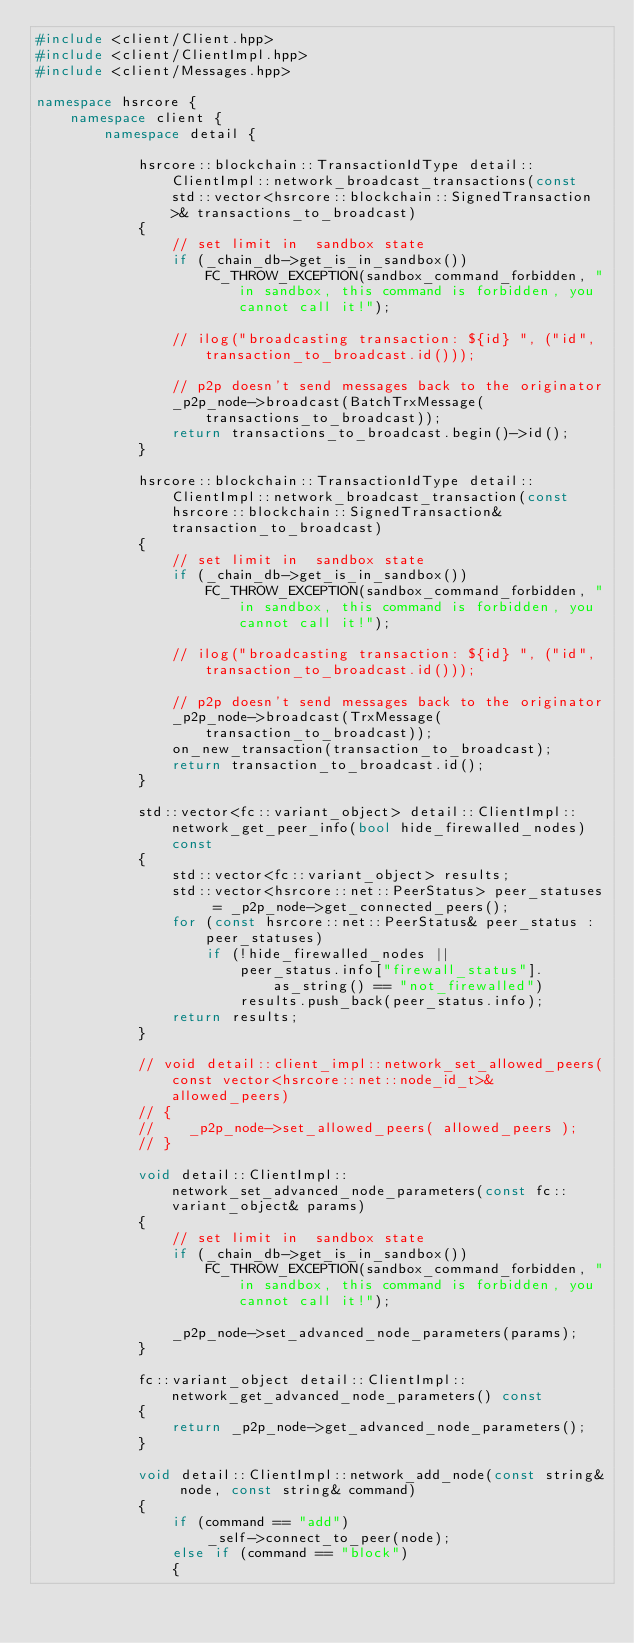<code> <loc_0><loc_0><loc_500><loc_500><_C++_>#include <client/Client.hpp>
#include <client/ClientImpl.hpp>
#include <client/Messages.hpp>

namespace hsrcore {
    namespace client {
        namespace detail {

            hsrcore::blockchain::TransactionIdType detail::ClientImpl::network_broadcast_transactions(const std::vector<hsrcore::blockchain::SignedTransaction>& transactions_to_broadcast)
            {
                // set limit in  sandbox state
                if (_chain_db->get_is_in_sandbox())
                    FC_THROW_EXCEPTION(sandbox_command_forbidden, "in sandbox, this command is forbidden, you cannot call it!");

                // ilog("broadcasting transaction: ${id} ", ("id", transaction_to_broadcast.id()));

                // p2p doesn't send messages back to the originator
                _p2p_node->broadcast(BatchTrxMessage(transactions_to_broadcast));
                return transactions_to_broadcast.begin()->id();
            }

            hsrcore::blockchain::TransactionIdType detail::ClientImpl::network_broadcast_transaction(const hsrcore::blockchain::SignedTransaction& transaction_to_broadcast)
            {
                // set limit in  sandbox state
                if (_chain_db->get_is_in_sandbox())
                    FC_THROW_EXCEPTION(sandbox_command_forbidden, "in sandbox, this command is forbidden, you cannot call it!");

                // ilog("broadcasting transaction: ${id} ", ("id", transaction_to_broadcast.id()));

                // p2p doesn't send messages back to the originator
                _p2p_node->broadcast(TrxMessage(transaction_to_broadcast));
                on_new_transaction(transaction_to_broadcast);
                return transaction_to_broadcast.id();
            }

            std::vector<fc::variant_object> detail::ClientImpl::network_get_peer_info(bool hide_firewalled_nodes)const
            {
                std::vector<fc::variant_object> results;
                std::vector<hsrcore::net::PeerStatus> peer_statuses = _p2p_node->get_connected_peers();
                for (const hsrcore::net::PeerStatus& peer_status : peer_statuses)
                    if (!hide_firewalled_nodes ||
                        peer_status.info["firewall_status"].as_string() == "not_firewalled")
                        results.push_back(peer_status.info);
                return results;
            }

            // void detail::client_impl::network_set_allowed_peers(const vector<hsrcore::net::node_id_t>& allowed_peers)
            // {
            //    _p2p_node->set_allowed_peers( allowed_peers );
            // }

            void detail::ClientImpl::network_set_advanced_node_parameters(const fc::variant_object& params)
            {
                // set limit in  sandbox state
                if (_chain_db->get_is_in_sandbox())
                    FC_THROW_EXCEPTION(sandbox_command_forbidden, "in sandbox, this command is forbidden, you cannot call it!");

                _p2p_node->set_advanced_node_parameters(params);
            }

            fc::variant_object detail::ClientImpl::network_get_advanced_node_parameters() const
            {
                return _p2p_node->get_advanced_node_parameters();
            }

            void detail::ClientImpl::network_add_node(const string& node, const string& command)
            {
                if (command == "add")
                    _self->connect_to_peer(node);
                else if (command == "block")
                {</code> 